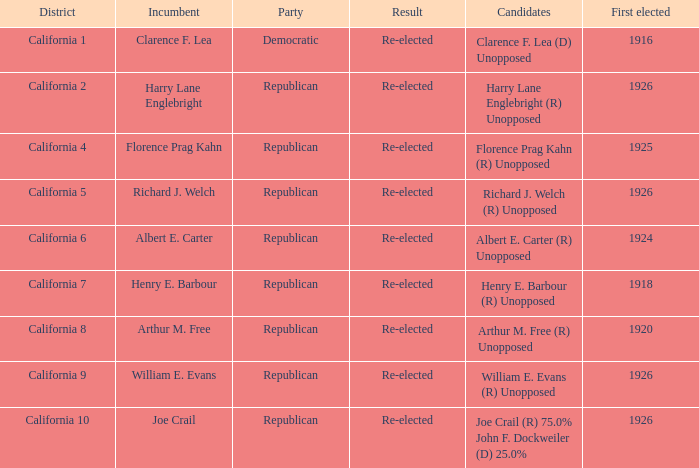What's the district with candidates being harry lane englebright (r) unopposed California 2. 